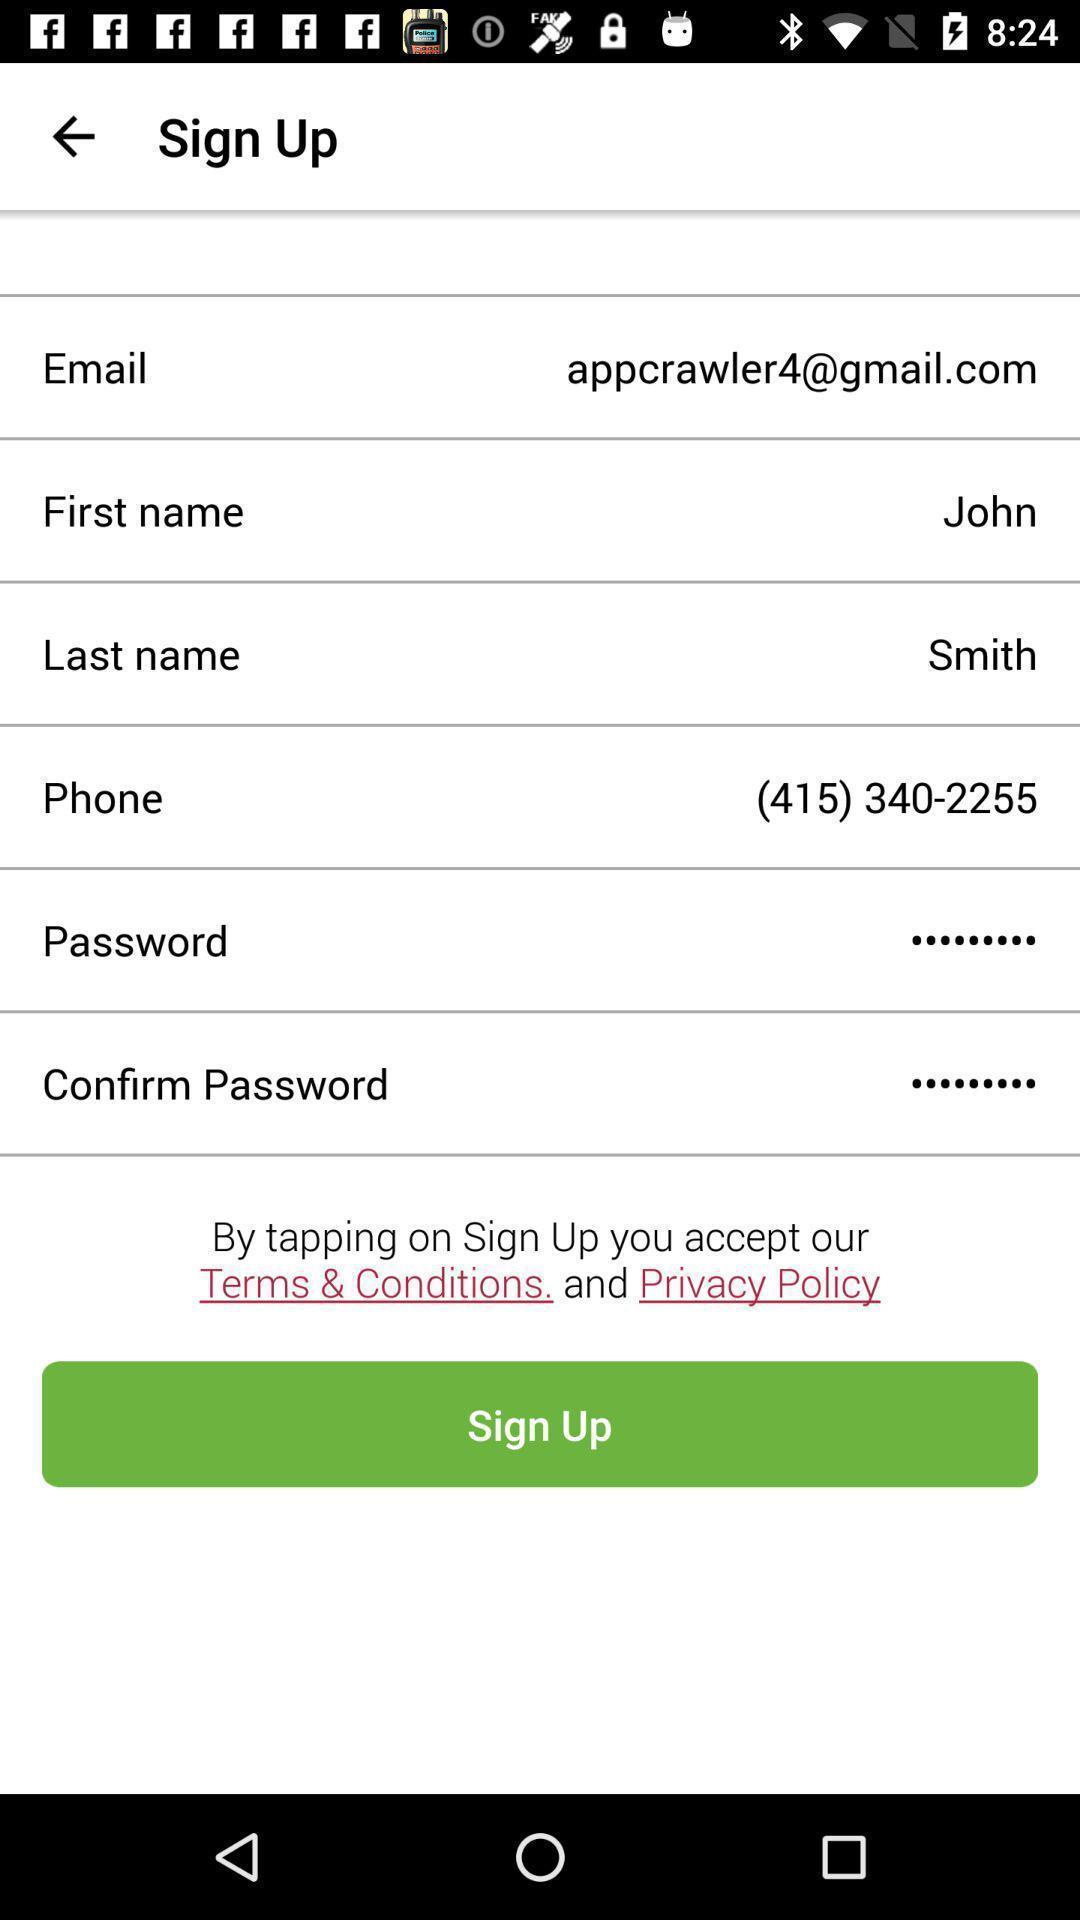Tell me what you see in this picture. Sign up page. 